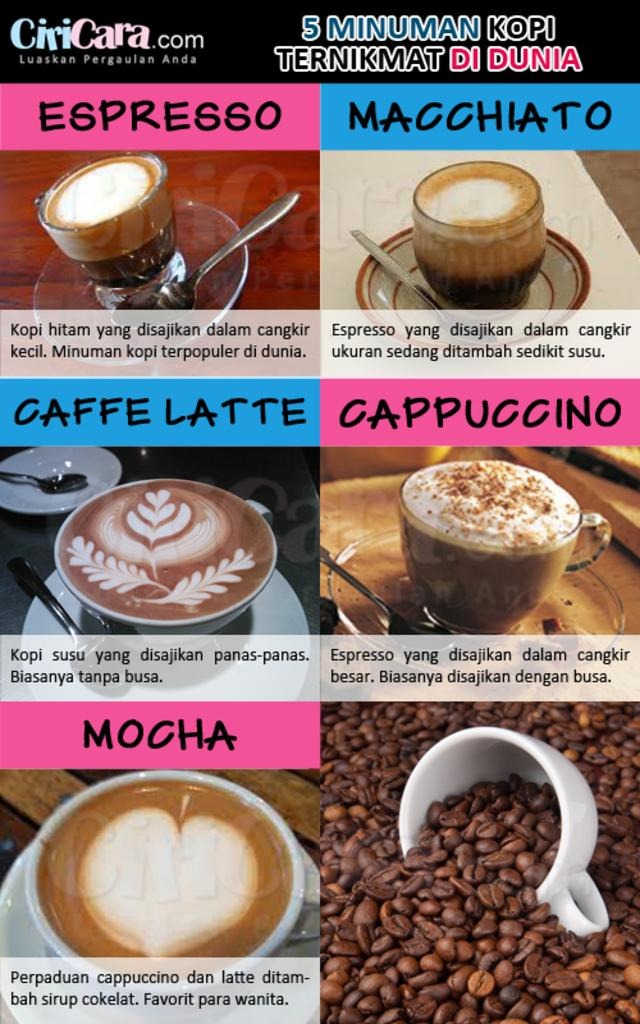What is depicted on the poster in the image? There is a poster of coffee and coffee beans in the image. What is in the cup that is visible in the image? There is a cup of coffee in the image. What is located beneath the cup in the image? There is a saucer in the image. What utensil is present in the image? There is a spoon in the image. Can you tell me how many giraffes are drinking coffee from the cup in the image? There are no giraffes present in the image, and the cup of coffee is not being consumed by any animals. What type of stew is being served in the image? There is no stew present in the image; it features a cup of coffee, a saucer, a spoon, and a poster of coffee and coffee beans. 